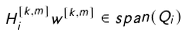Convert formula to latex. <formula><loc_0><loc_0><loc_500><loc_500>H _ { i } ^ { [ k , m ] } w ^ { [ k , m ] } \in s p a n ( Q _ { i } )</formula> 